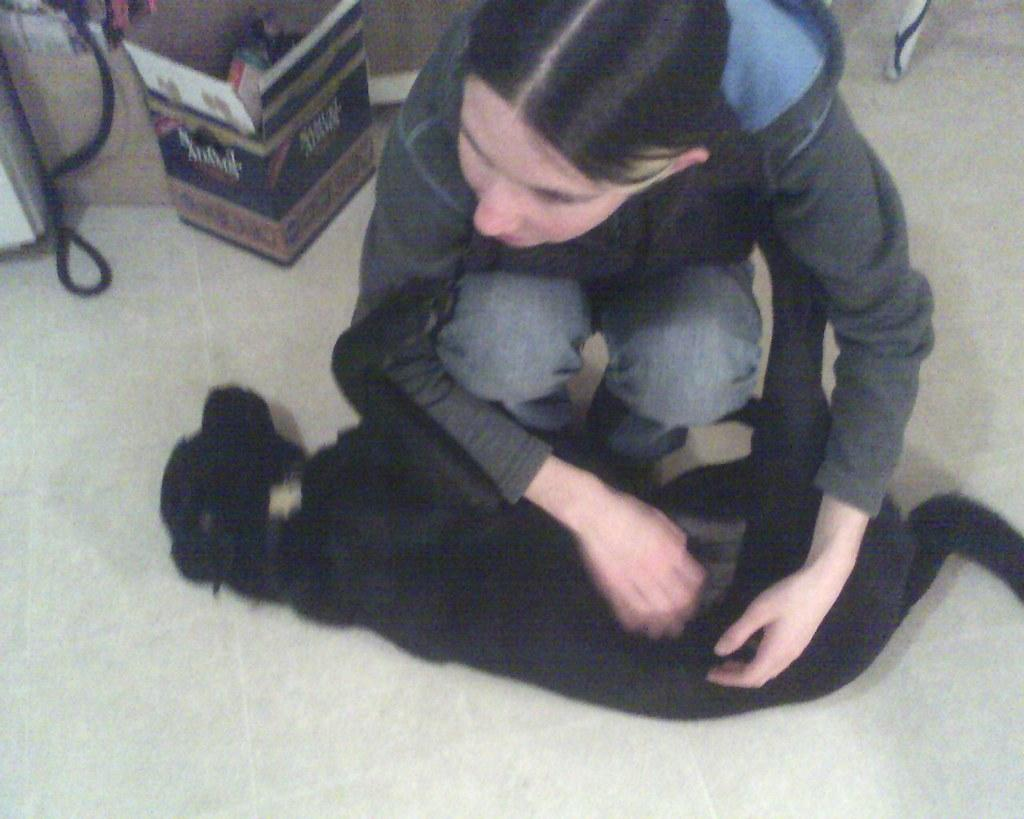What is in the foreground of the image? There is a dog lying in the foreground of the image. What is the woman in the image doing? The woman is bending in the image. What type of bushes can be seen in the image? There are no bushes present in the image. How does the sugar affect the waves in the image? There are no waves or sugar present in the image. 